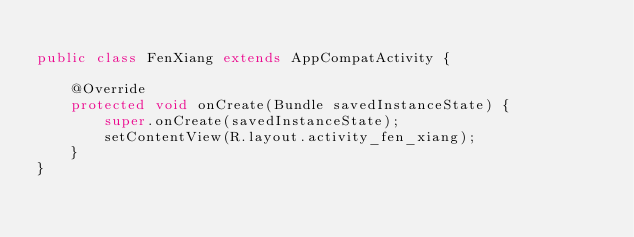Convert code to text. <code><loc_0><loc_0><loc_500><loc_500><_Java_>
public class FenXiang extends AppCompatActivity {

    @Override
    protected void onCreate(Bundle savedInstanceState) {
        super.onCreate(savedInstanceState);
        setContentView(R.layout.activity_fen_xiang);
    }
}
</code> 